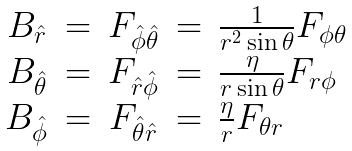<formula> <loc_0><loc_0><loc_500><loc_500>\begin{array} { c c c c l } B _ { \hat { r } } & = & F _ { \hat { \phi } \hat { \theta } } & = & \frac { 1 } { r ^ { 2 } \sin \theta } F _ { \phi \theta } \\ B _ { \hat { \theta } } & = & F _ { \hat { r } \hat { \phi } } & = & \frac { \eta } { r \sin \theta } F _ { r \phi } \\ B _ { \hat { \phi } } & = & F _ { \hat { \theta } \hat { r } } & = & \frac { \eta } { r } F _ { \theta r } \\ \end{array}</formula> 